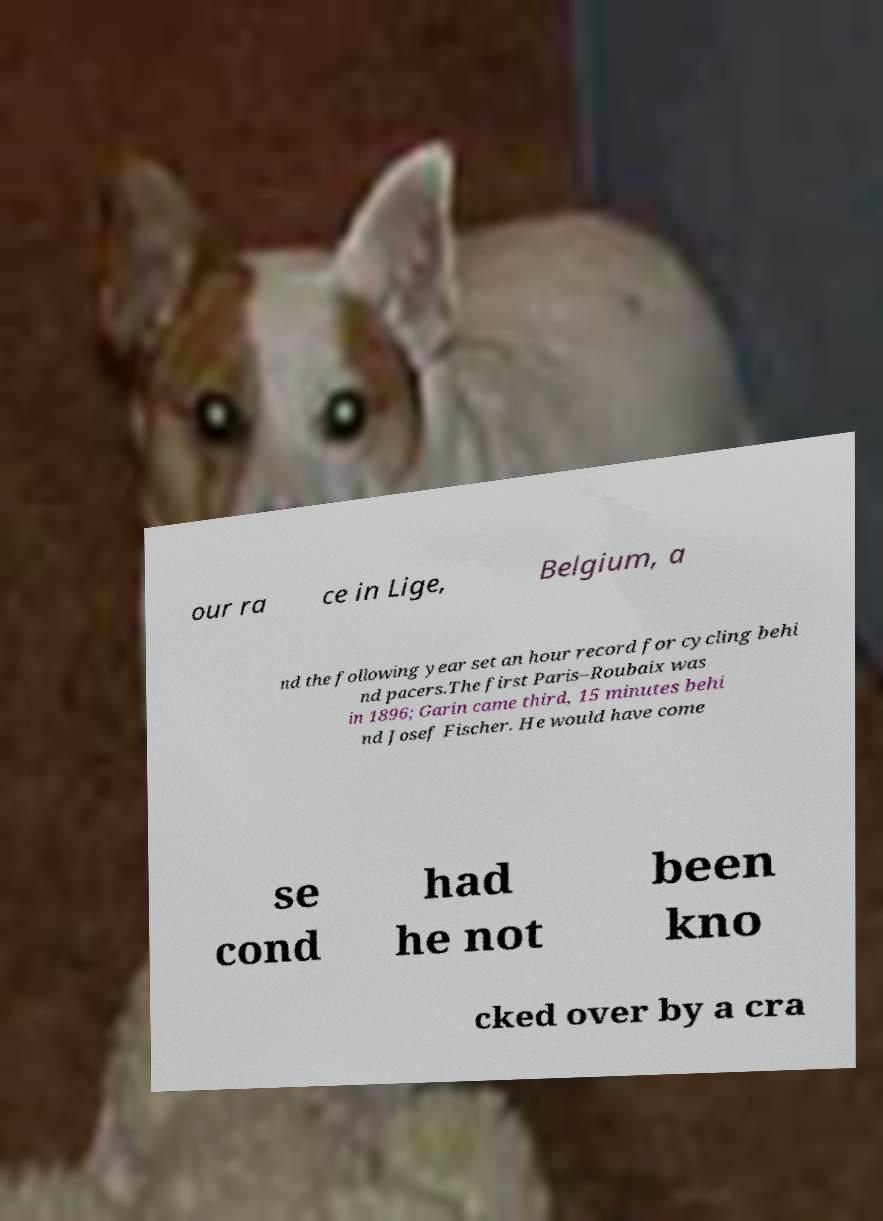Please read and relay the text visible in this image. What does it say? our ra ce in Lige, Belgium, a nd the following year set an hour record for cycling behi nd pacers.The first Paris–Roubaix was in 1896; Garin came third, 15 minutes behi nd Josef Fischer. He would have come se cond had he not been kno cked over by a cra 